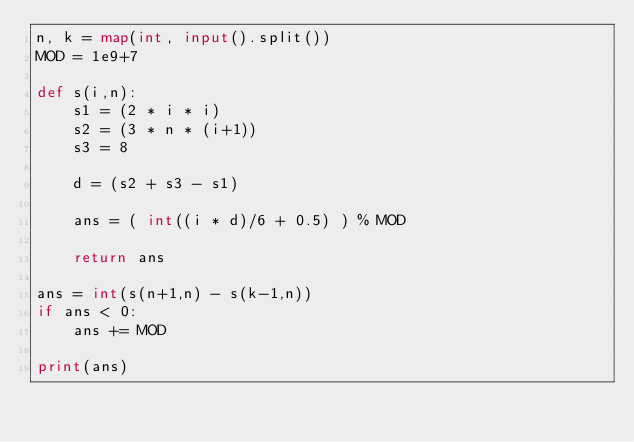Convert code to text. <code><loc_0><loc_0><loc_500><loc_500><_Python_>n, k = map(int, input().split())
MOD = 1e9+7

def s(i,n):
    s1 = (2 * i * i)
    s2 = (3 * n * (i+1)) 
    s3 = 8

    d = (s2 + s3 - s1)

    ans = ( int((i * d)/6 + 0.5) ) % MOD
    
    return ans

ans = int(s(n+1,n) - s(k-1,n))
if ans < 0:
    ans += MOD

print(ans)</code> 